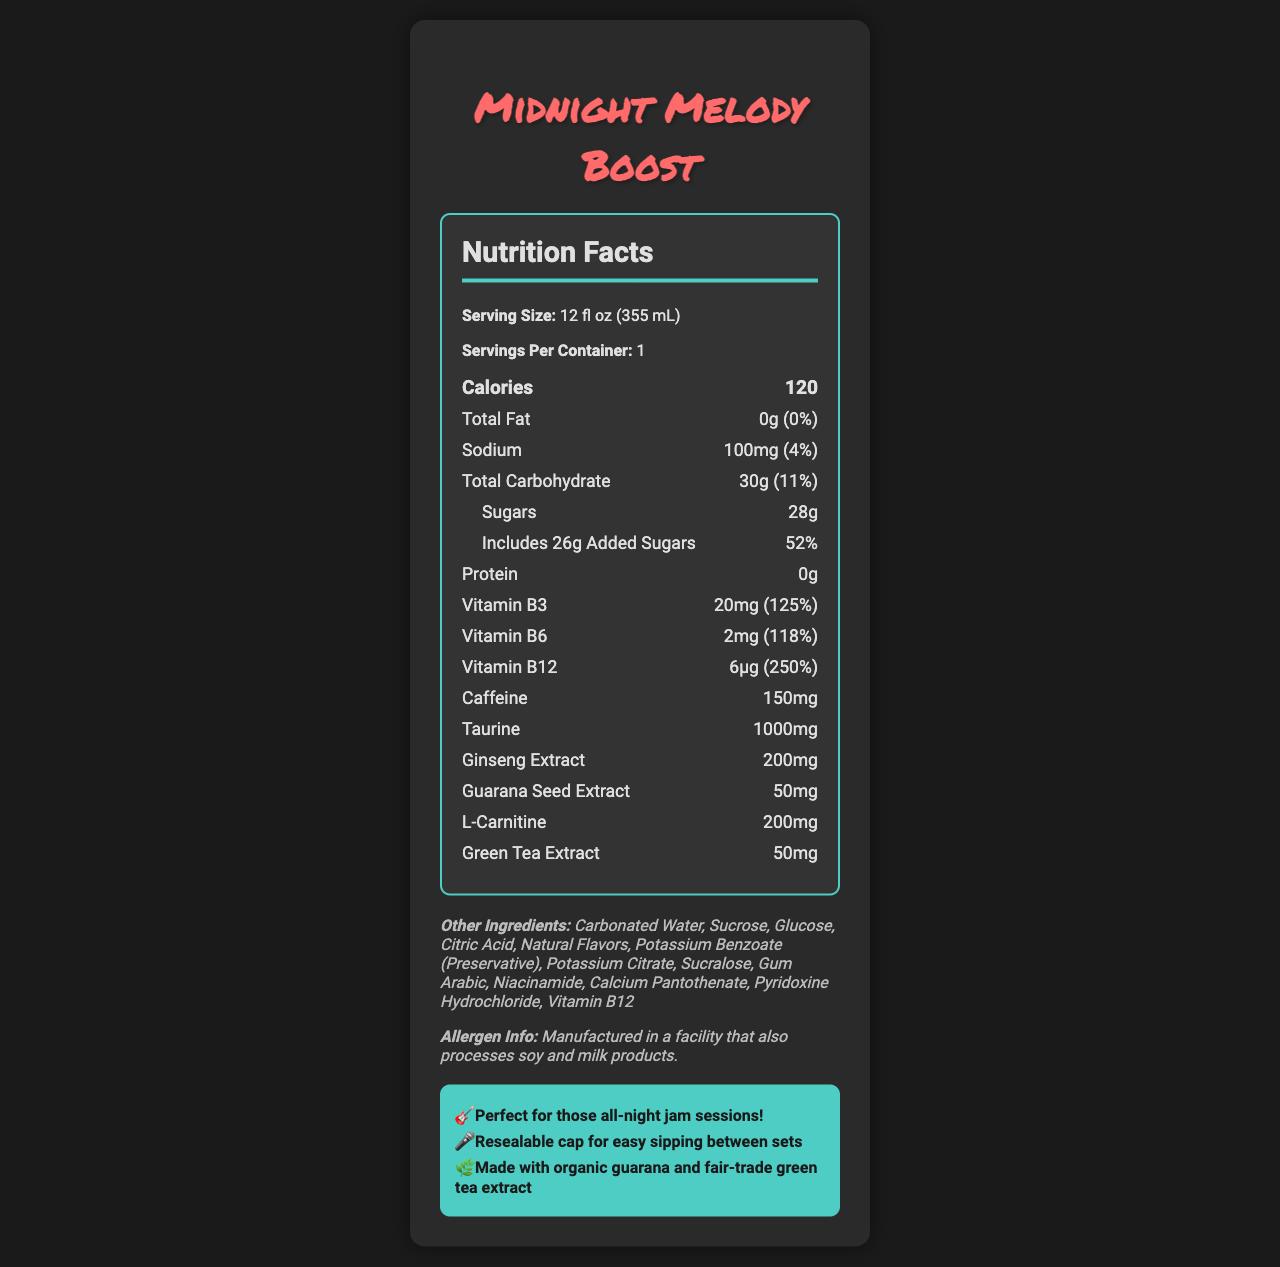What is the serving size of the Midnight Melody Boost? The serving size is explicitly stated at the beginning of the document under "Nutrition Facts."
Answer: 12 fl oz (355 mL) How many calories are in a single serving of this drink? The number of calories per serving is prominently displayed in the document.
Answer: 120 What is the total carbohydrate content per serving? Total carbohydrate content is listed under the nutrition facts section.
Answer: 30g How much Vitamin B12 does the drink contain? Vitamin B12 content is provided under the nutrition information along with the percentage daily value.
Answer: 6μg What are the allergens mentioned in the document? The allergen information specifies that it is manufactured in a facility that processes soy and milk products.
Answer: Soy and milk products How much caffeine is in one serving of Midnight Melody Boost? The document lists the caffeine content clearly under the ingredient information.
Answer: 150mg What percentage of the daily value for sodium does this drink provide? The sodium percentage is listed as part of the nutrition facts.
Answer: 4% What is the amount of added sugars in this drink? The document specifies the amount of sugars and includes a breakdown of added sugars.
Answer: 26g What are the main ingredients besides the active compounds like caffeine and taurine? The document lists the other ingredients which include items like Carbonated Water, Sucrose, Glucose, Citric Acid, etc.
Answer: Carbonated Water, Sucrose, Glucose, Citric Acid, Natural Flavors, etc. Does this drink contain any protein? The nutrition facts explicitly state that the protein content is 0g.
Answer: No Which vitamin has the highest percentage daily value in this drink? A. Vitamin B3 B. Vitamin B6 C. Vitamin B12 Vitamin B12 has the highest percentage daily value at 250%, compared to Vitamin B3 at 125% and Vitamin B6 at 118%.
Answer: C What is the total daily value percentage for sugars in one serving of the drink? A. 26% B. 52% C. 11% D. 53% The total daily value percentage for sugars is 52%, specifically mentioned in the nutrition facts.
Answer: B Which of the following extracts is present in Midnight Melody Boost? A. Ginger Extract B. Ginseng Extract C. Chamomile Extract The document lists Ginseng Extract as one of the ingredients.
Answer: B Is the Midnight Melody Boost labeled as "Guitarist approved"? The document includes a specific note saying "Guitarist approved: Perfect for those all-night jam sessions!"
Answer: Yes What is the drink's recommendability for musicians? The musician notes section specifically mentions these attributes, making it suitable for musicians.
Answer: It suggests that the drink is perfect for all-night jam sessions and is gig-ready with a resealable cap. Can you tell if this drink is gluten-free? The document does not provide information regarding gluten content.
Answer: Not enough information Describe the overall content and purpose of the document. The document is structured to give a full overview of the nutritional aspects and market appeal of the energy drink, aimed at indie musicians who need a boost for their performances.
Answer: The document provides detailed nutritional information for the Midnight Melody Boost energy drink. It includes specifics such as serving size, calories, and the amounts of various nutrients, vitamins, and compounds like caffeine and taurine. Additionally, it mentions allergen information and describes the drink as suitable for musicians, especially for long night gigs. 